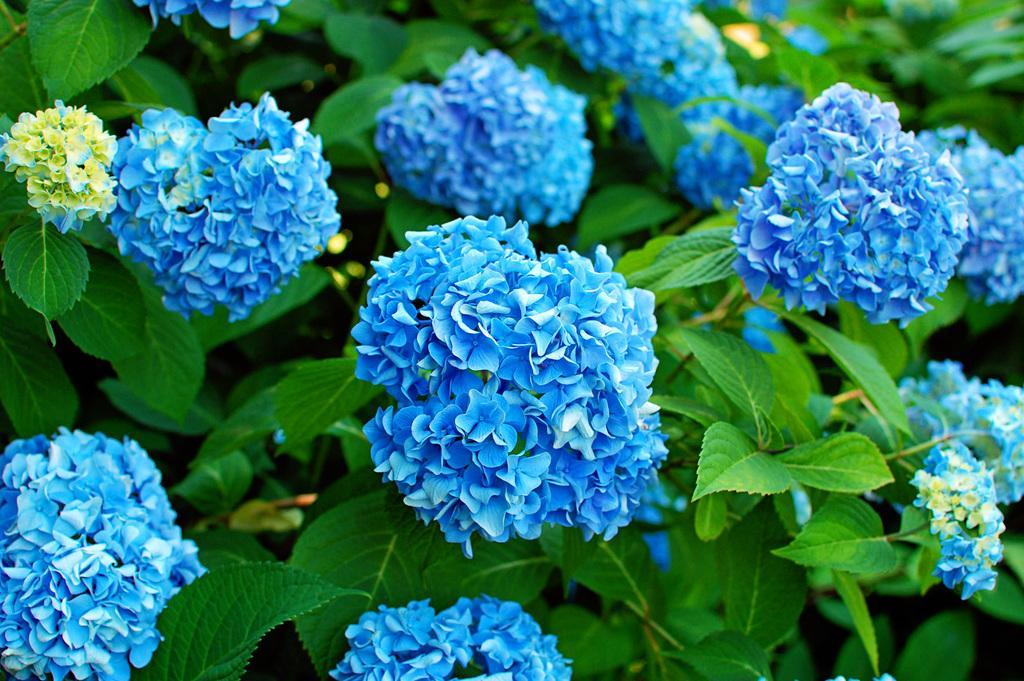Please provide a concise description of this image. In this image I can see floral plants. 